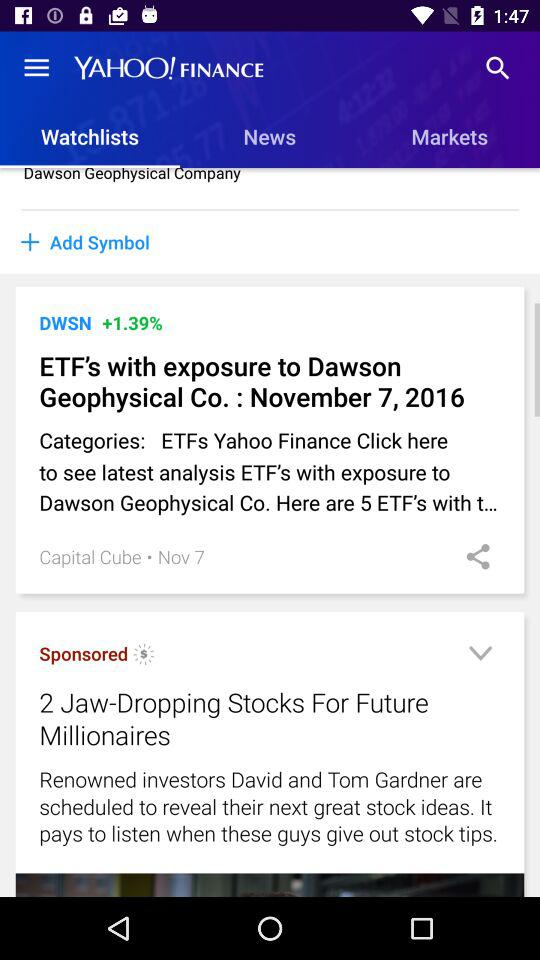What is the app name? The app name is "YAHOO! FINANCE". 